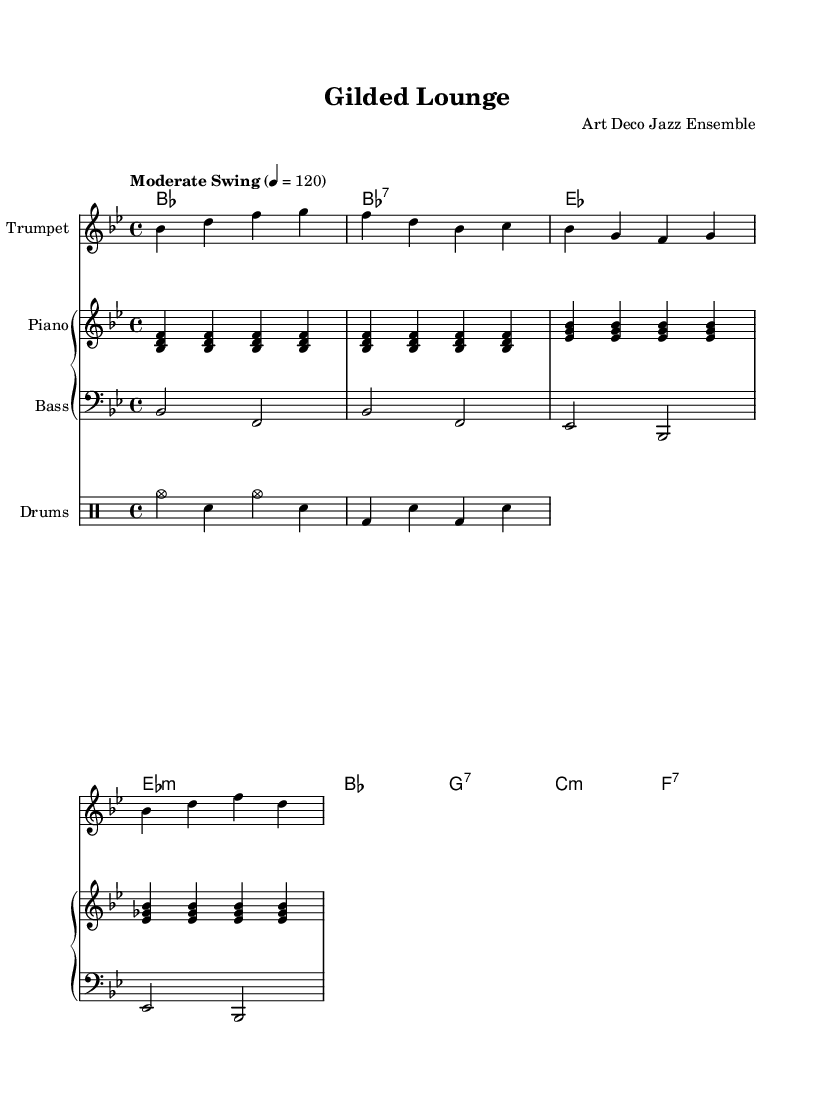What is the title of this piece? The title is displayed in the header section of the sheet music as "Gilded Lounge."
Answer: Gilded Lounge What is the key signature of this music? The key signature shows two flats (B♭ and E♭), indicating it is in B♭ major.
Answer: B♭ major What is the time signature of this music? The time signature is indicated at the beginning of the score, which is 4/4 time, meaning that there are four beats per measure.
Answer: 4/4 What is the tempo marking of this piece? The tempo is marked "Moderate Swing" at a metronome marking of 120 beats per minute, indicating a swing feel.
Answer: Moderate Swing, 120 Name one instrument featured in this piece. The score specifies "Trumpet" as one of the instruments, as shown in the melody section.
Answer: Trumpet How many measures does the melody contain? The melody shows a total of 8 measures, which can be counted in the melody section.
Answer: 8 measures What type of chord is shown at measure 2? The chord in measure 2 is labeled as a B♭7 chord in the chord names section underneath the melody.
Answer: B♭7 